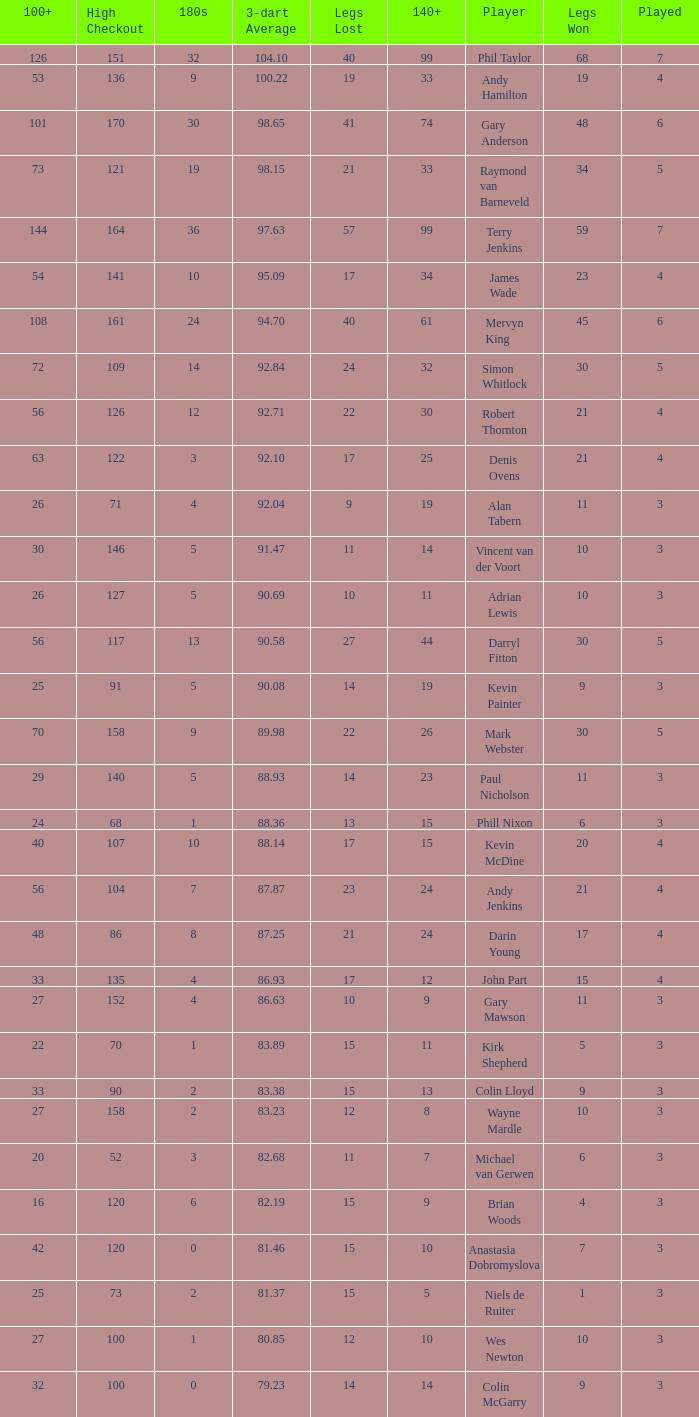What is the total number of 3-dart average when legs lost is larger than 41, and played is larger than 7? 0.0. 